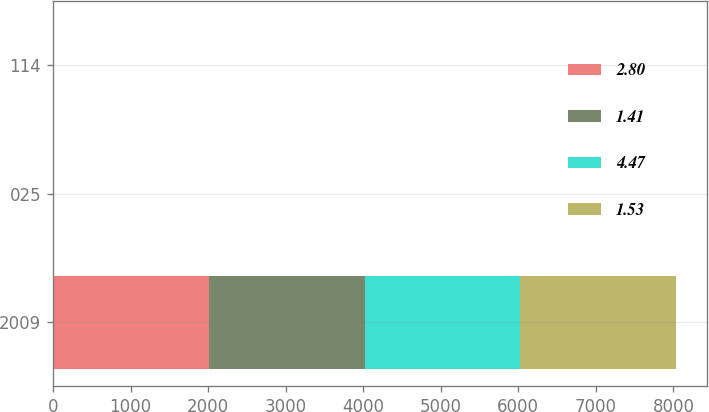Convert chart. <chart><loc_0><loc_0><loc_500><loc_500><stacked_bar_chart><ecel><fcel>2009<fcel>025<fcel>114<nl><fcel>2.8<fcel>2009<fcel>0.25<fcel>1.53<nl><fcel>1.41<fcel>2009<fcel>3.97<fcel>4.47<nl><fcel>4.47<fcel>2008<fcel>0.25<fcel>0.75<nl><fcel>1.53<fcel>2008<fcel>1.43<fcel>1.41<nl></chart> 